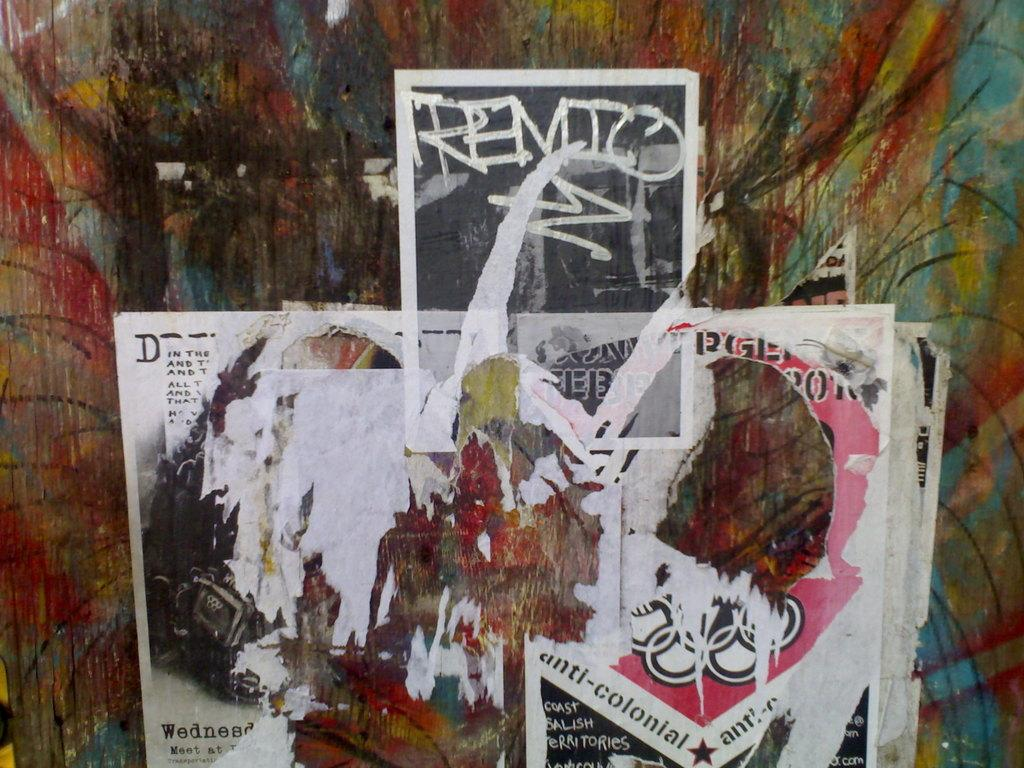What is present on the wall in the image? There is a painting and newspapers on the wall. What is the condition of the newspapers on the wall? The newspapers are torn into pieces. Can you describe the painting on the wall? Unfortunately, the facts provided do not give any details about the painting. What type of road can be seen in the image? There is no road present in the image; it features a wall with a painting and torn newspapers. How does the tank maintain its balance in the image? There is no tank present in the image, so the question of balance is not applicable. 